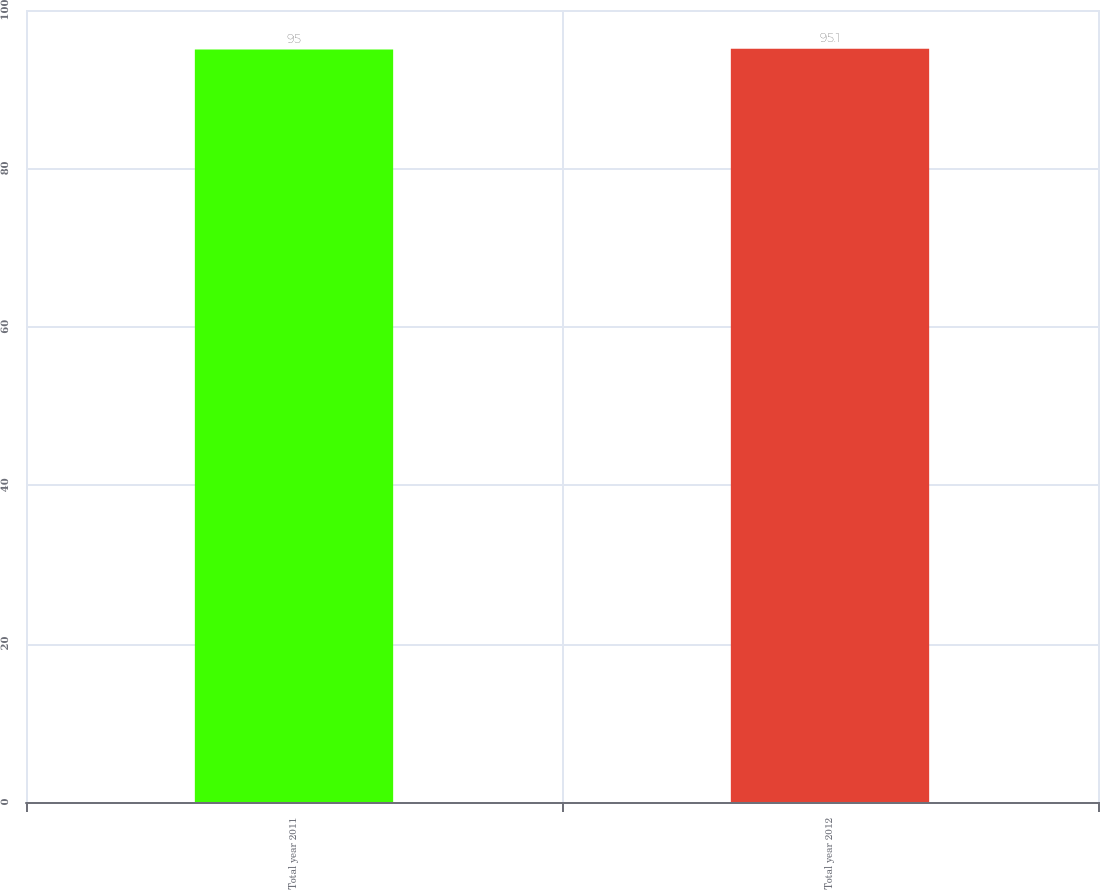Convert chart to OTSL. <chart><loc_0><loc_0><loc_500><loc_500><bar_chart><fcel>Total year 2011<fcel>Total year 2012<nl><fcel>95<fcel>95.1<nl></chart> 